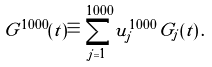<formula> <loc_0><loc_0><loc_500><loc_500>G ^ { 1 0 0 0 } ( t ) \equiv \sum _ { j = 1 } ^ { 1 0 0 0 } u ^ { 1 0 0 0 } _ { j } \, G _ { j } ( t ) \, .</formula> 